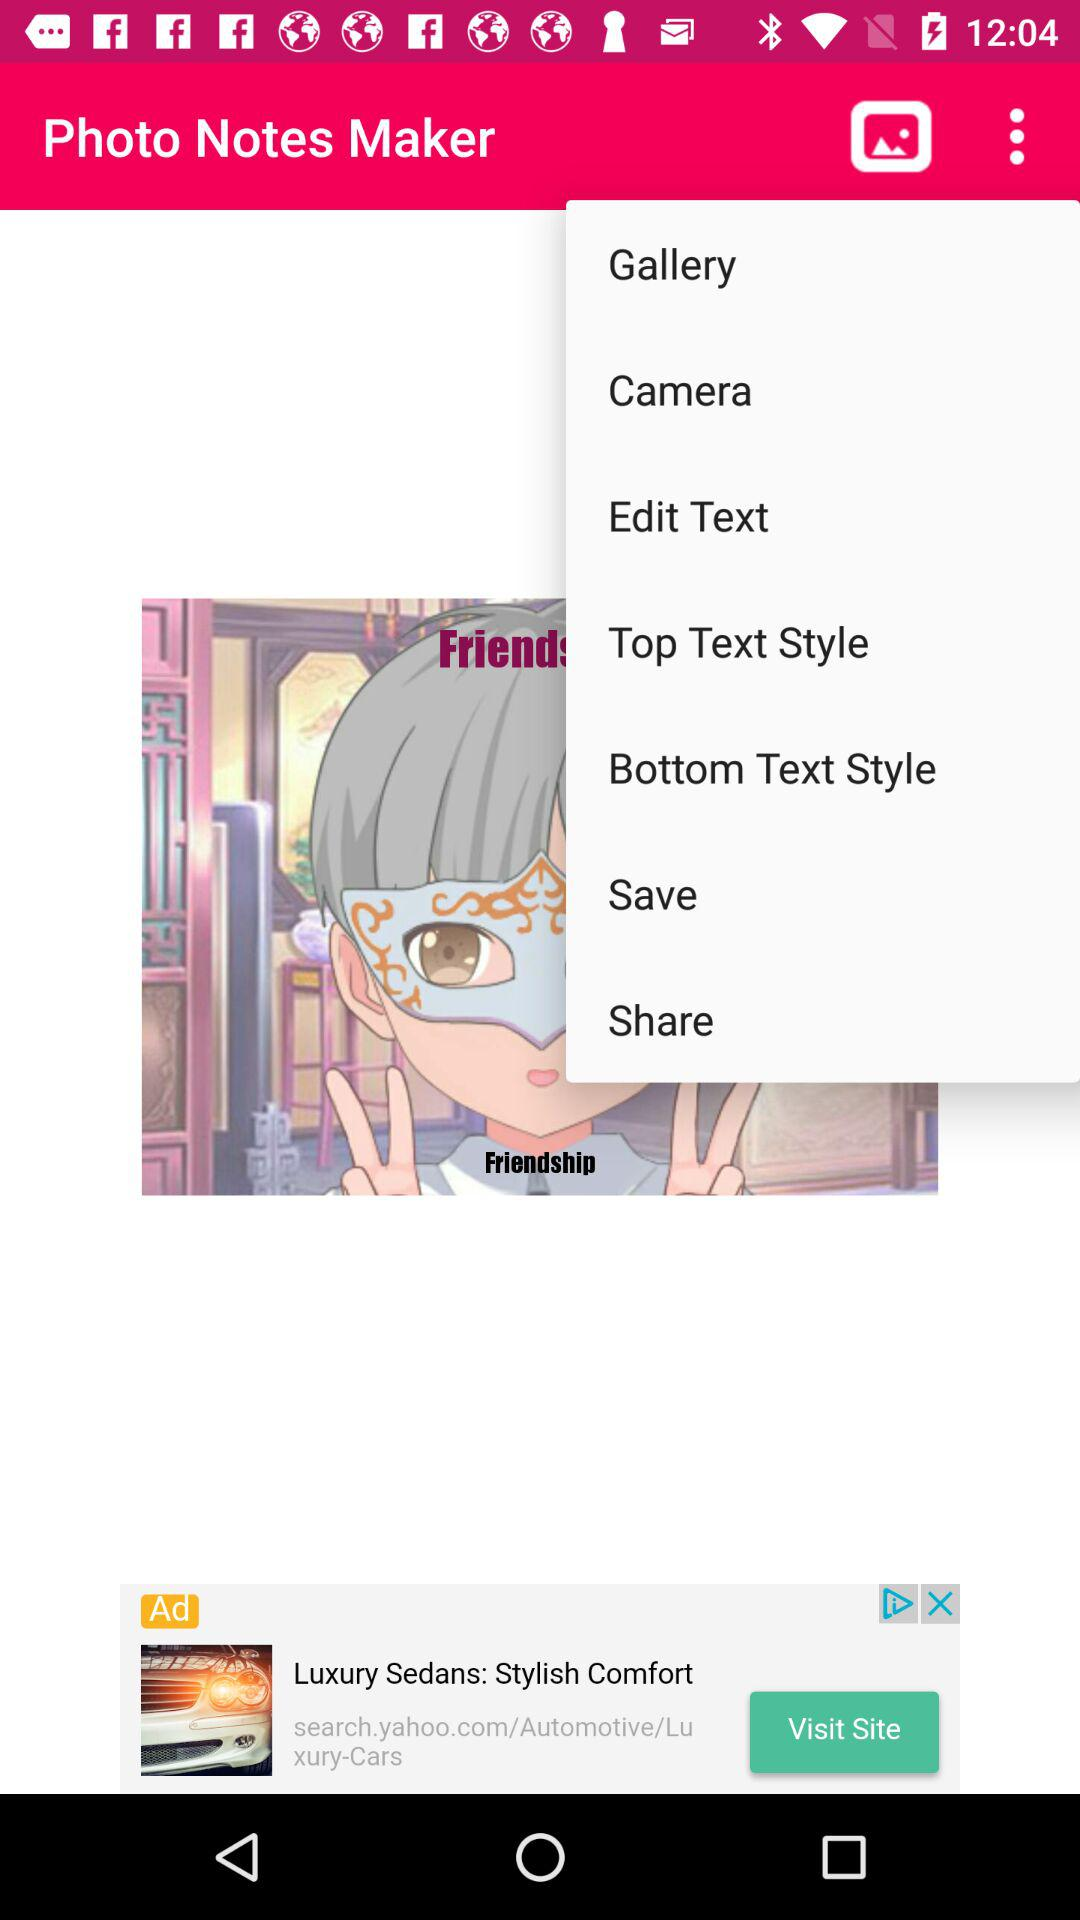What is the name of the application? The application name is "Photo Notes Maker". 